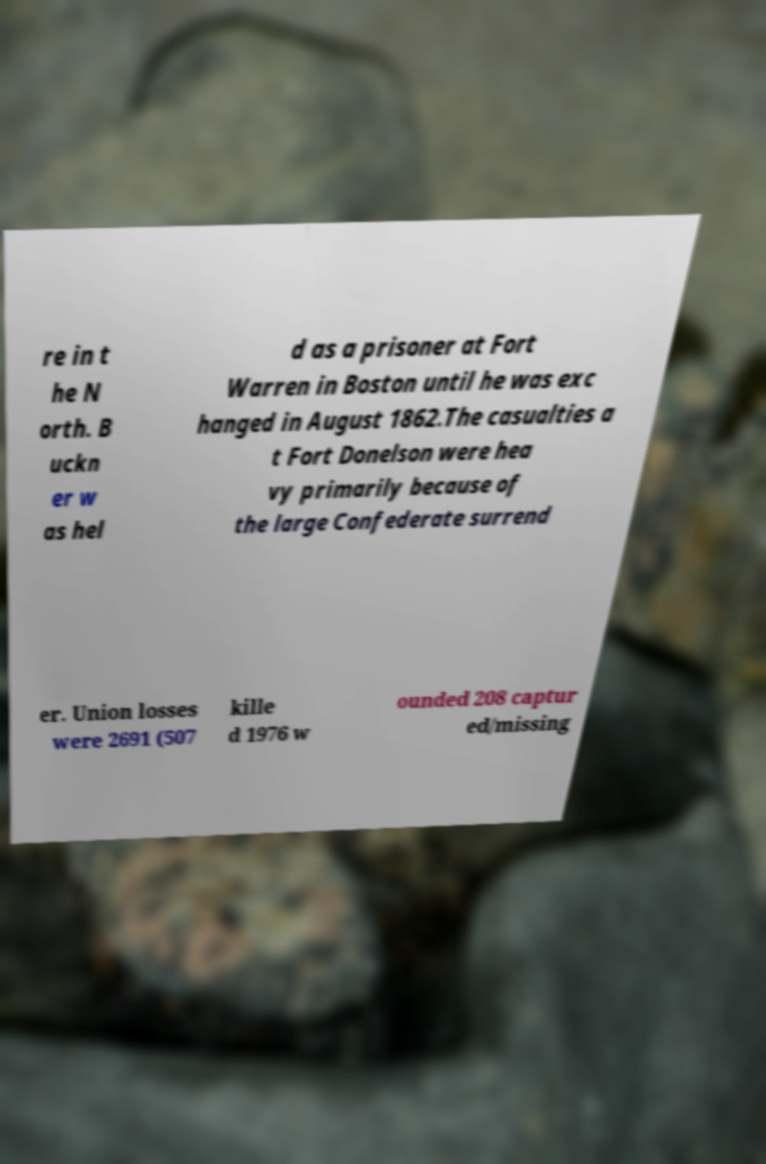Could you assist in decoding the text presented in this image and type it out clearly? re in t he N orth. B uckn er w as hel d as a prisoner at Fort Warren in Boston until he was exc hanged in August 1862.The casualties a t Fort Donelson were hea vy primarily because of the large Confederate surrend er. Union losses were 2691 (507 kille d 1976 w ounded 208 captur ed/missing 